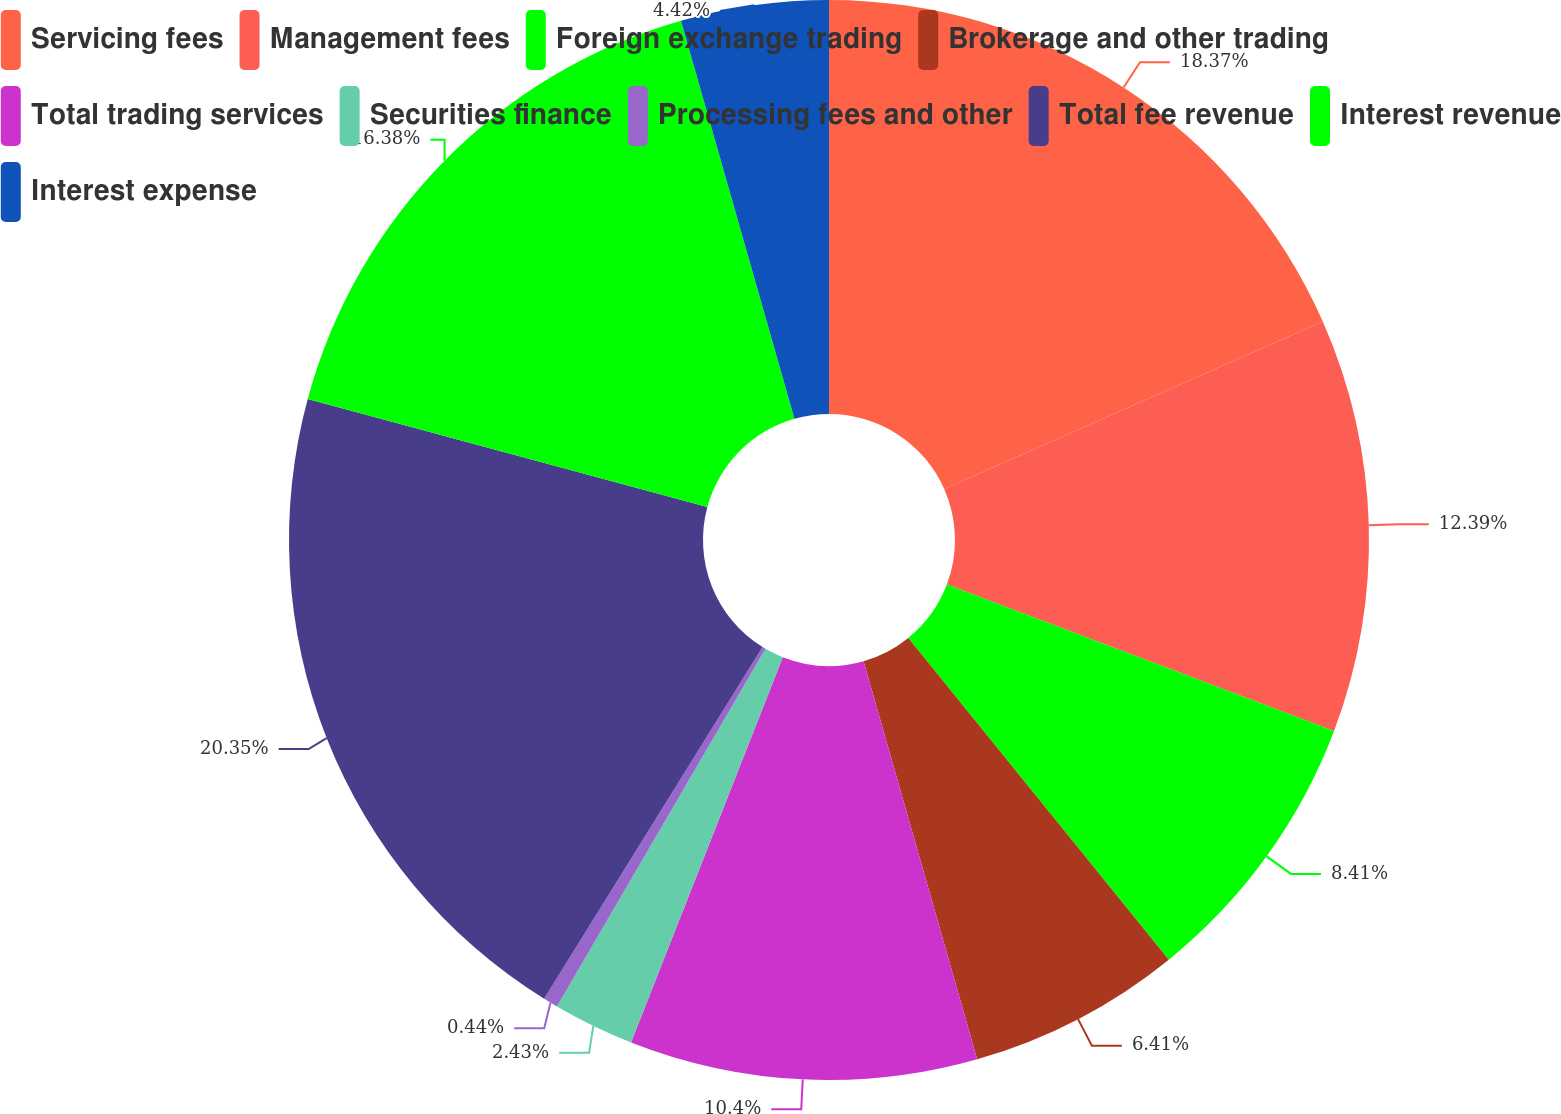<chart> <loc_0><loc_0><loc_500><loc_500><pie_chart><fcel>Servicing fees<fcel>Management fees<fcel>Foreign exchange trading<fcel>Brokerage and other trading<fcel>Total trading services<fcel>Securities finance<fcel>Processing fees and other<fcel>Total fee revenue<fcel>Interest revenue<fcel>Interest expense<nl><fcel>18.37%<fcel>12.39%<fcel>8.41%<fcel>6.41%<fcel>10.4%<fcel>2.43%<fcel>0.44%<fcel>20.36%<fcel>16.38%<fcel>4.42%<nl></chart> 